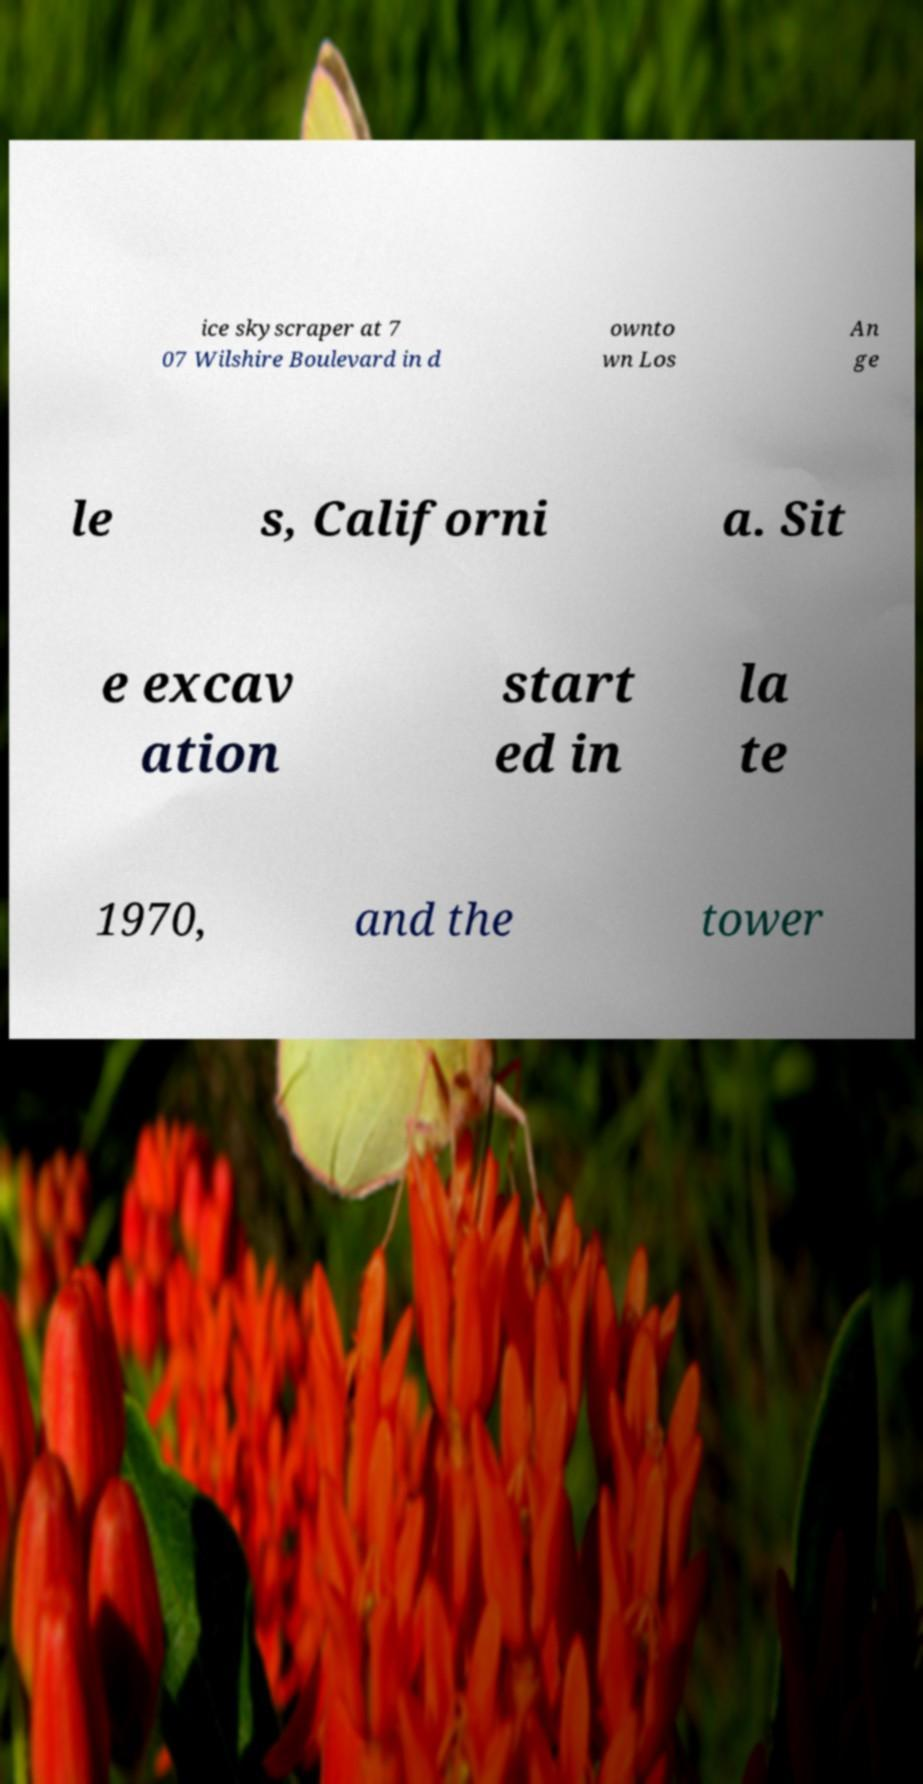Please identify and transcribe the text found in this image. ice skyscraper at 7 07 Wilshire Boulevard in d ownto wn Los An ge le s, Californi a. Sit e excav ation start ed in la te 1970, and the tower 